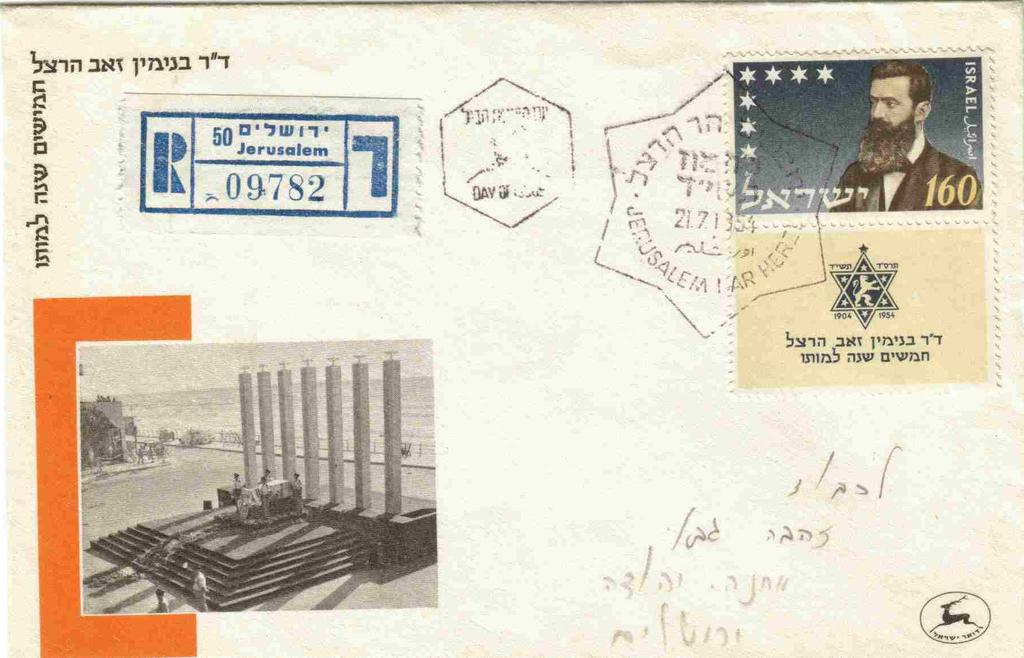What number is on the postage stamp?
Provide a succinct answer. 160. 160 postage stamp?
Make the answer very short. Yes. 